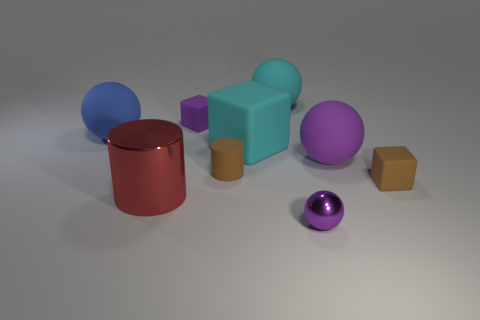What number of small blocks are the same color as the small cylinder?
Provide a short and direct response. 1. Are there fewer objects that are on the left side of the small brown matte cylinder than things in front of the cyan cube?
Offer a terse response. Yes. There is a tiny purple object that is on the right side of the purple cube; is it the same shape as the large purple matte thing?
Keep it short and to the point. Yes. Do the purple sphere in front of the big shiny object and the red cylinder have the same material?
Provide a succinct answer. Yes. The big cyan object that is in front of the sphere that is on the left side of the small matte block behind the big blue sphere is made of what material?
Offer a very short reply. Rubber. How many other objects are the same shape as the blue rubber object?
Provide a short and direct response. 3. The ball on the left side of the large shiny cylinder is what color?
Ensure brevity in your answer.  Blue. There is a purple thing in front of the large red metallic object that is in front of the large blue rubber ball; what number of small rubber blocks are to the right of it?
Your answer should be compact. 1. There is a small thing in front of the large metallic thing; how many shiny cylinders are on the right side of it?
Ensure brevity in your answer.  0. There is a brown block; how many objects are behind it?
Keep it short and to the point. 6. 